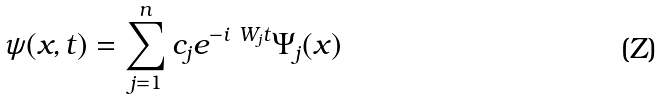<formula> <loc_0><loc_0><loc_500><loc_500>\psi ( x , t ) = \sum _ { j = 1 } ^ { n } c _ { j } e ^ { - i \ W _ { j } t } \Psi _ { j } ( x )</formula> 